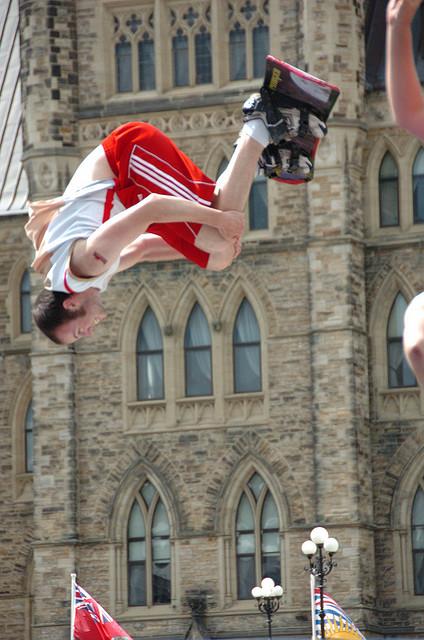Is he wearing knee pads?
Concise answer only. No. What is this man doing upside down?
Be succinct. Skateboard trick. What kind of building is shown?
Be succinct. Church. 